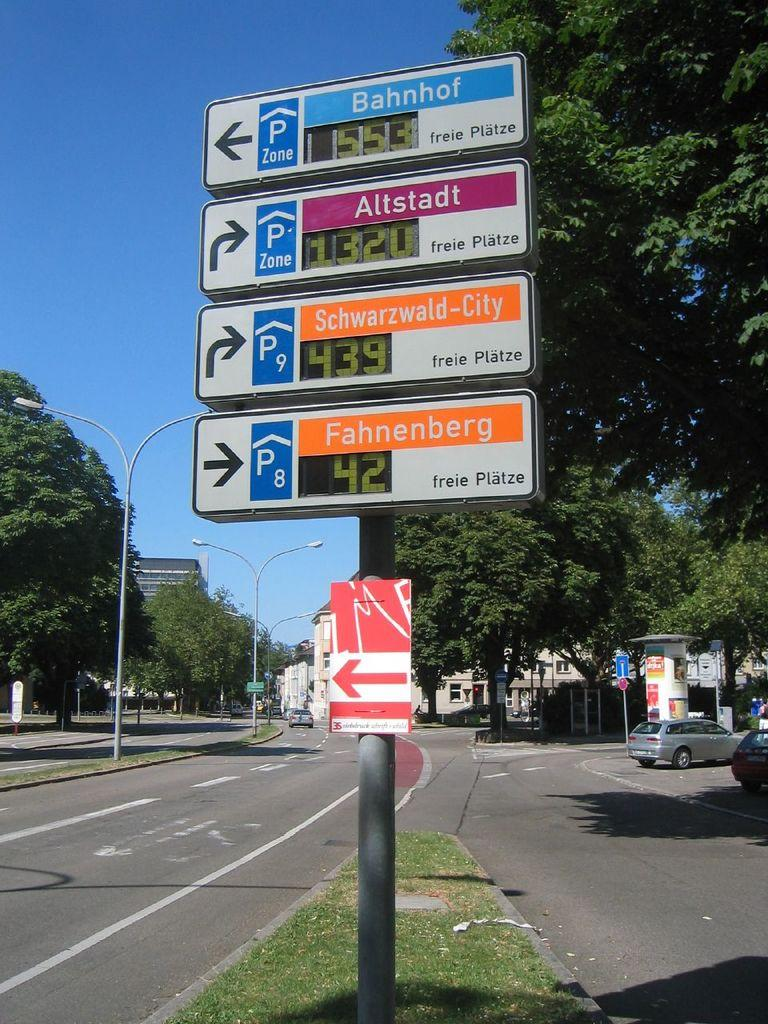<image>
Render a clear and concise summary of the photo. A bank of directional signs that show Fahnenberg to be 42 km to the left. 